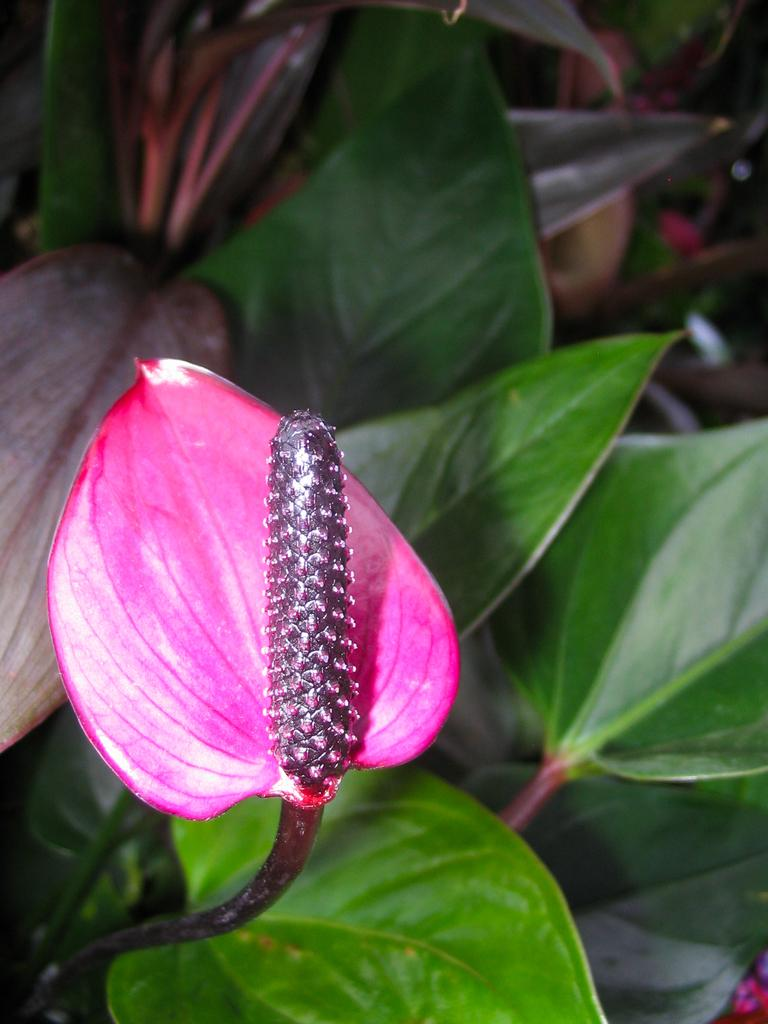What type of plant can be seen in the image? There is a flower in the image. What else is present on the plant besides the flower? There are leaves in the image. What type of creature is causing trouble for the flower in the image? There is no creature present in the image, and no trouble is depicted. 